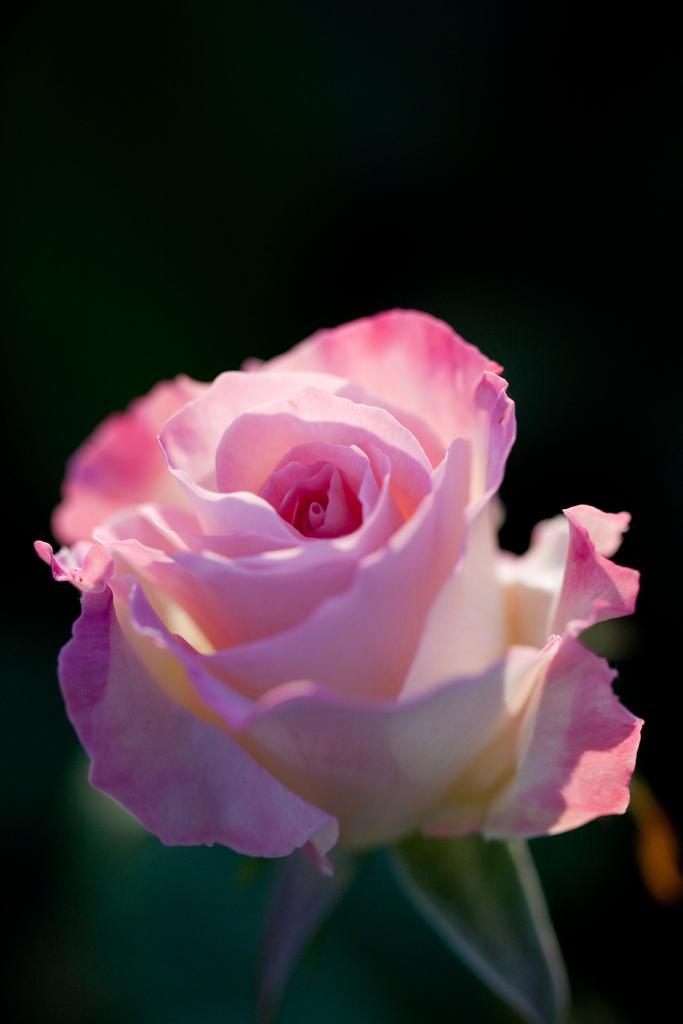Can you describe this image briefly? In this image, I can see a pink flower and there is a dark background. 